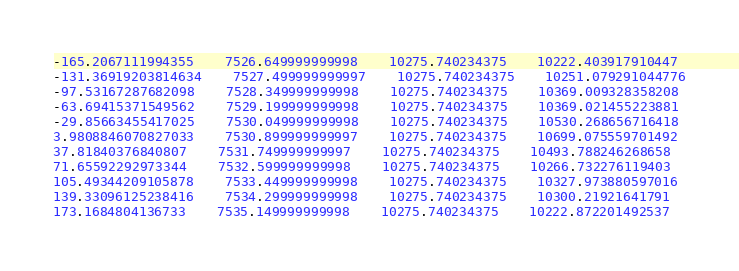Convert code to text. <code><loc_0><loc_0><loc_500><loc_500><_SQL_>-165.2067111994355	7526.649999999998	10275.740234375	10222.403917910447
-131.36919203814634	7527.499999999997	10275.740234375	10251.079291044776
-97.53167287682098	7528.349999999998	10275.740234375	10369.009328358208
-63.69415371549562	7529.199999999998	10275.740234375	10369.021455223881
-29.85663455417025	7530.049999999998	10275.740234375	10530.268656716418
3.9808846070827033	7530.899999999997	10275.740234375	10699.075559701492
37.81840376840807	7531.749999999997	10275.740234375	10493.788246268658
71.65592292973344	7532.599999999998	10275.740234375	10266.732276119403
105.49344209105878	7533.449999999998	10275.740234375	10327.973880597016
139.33096125238416	7534.299999999998	10275.740234375	10300.21921641791
173.1684804136733	7535.149999999998	10275.740234375	10222.872201492537</code> 